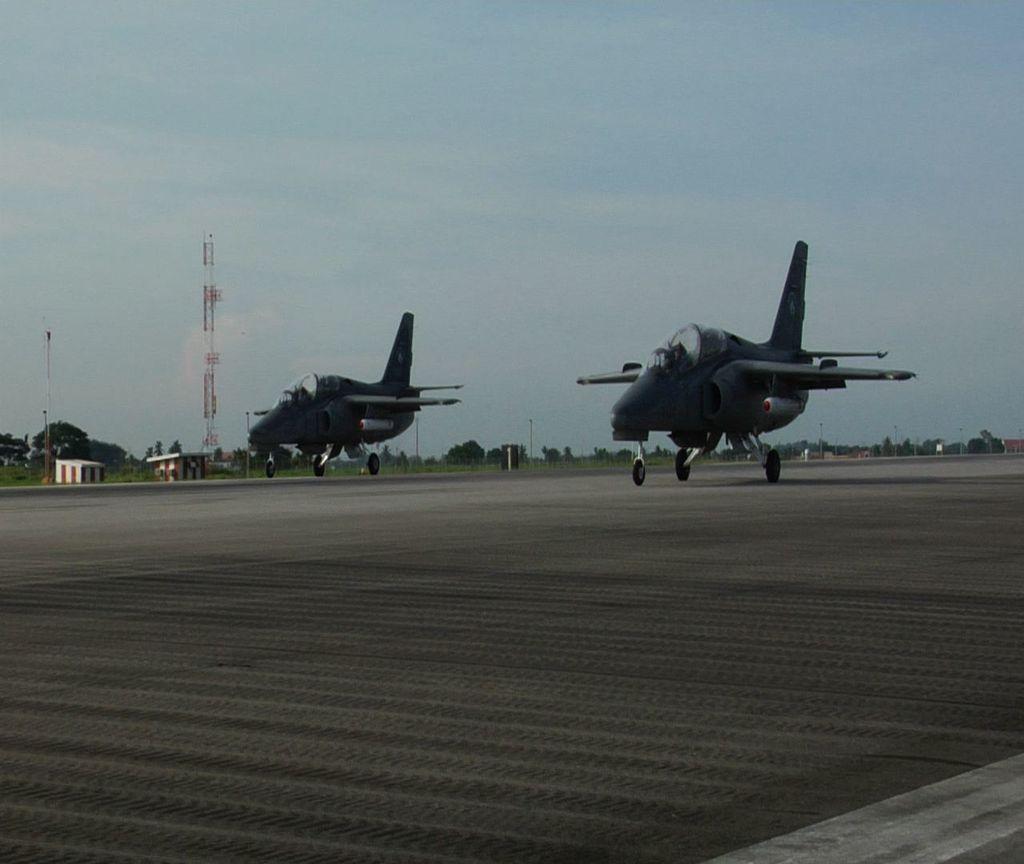Please provide a concise description of this image. In this image I can see two aeroplanes on the floor and I can see wheels. Back Side I can see a tower,trees,poles and sheds. The sky is in blue and white color. 